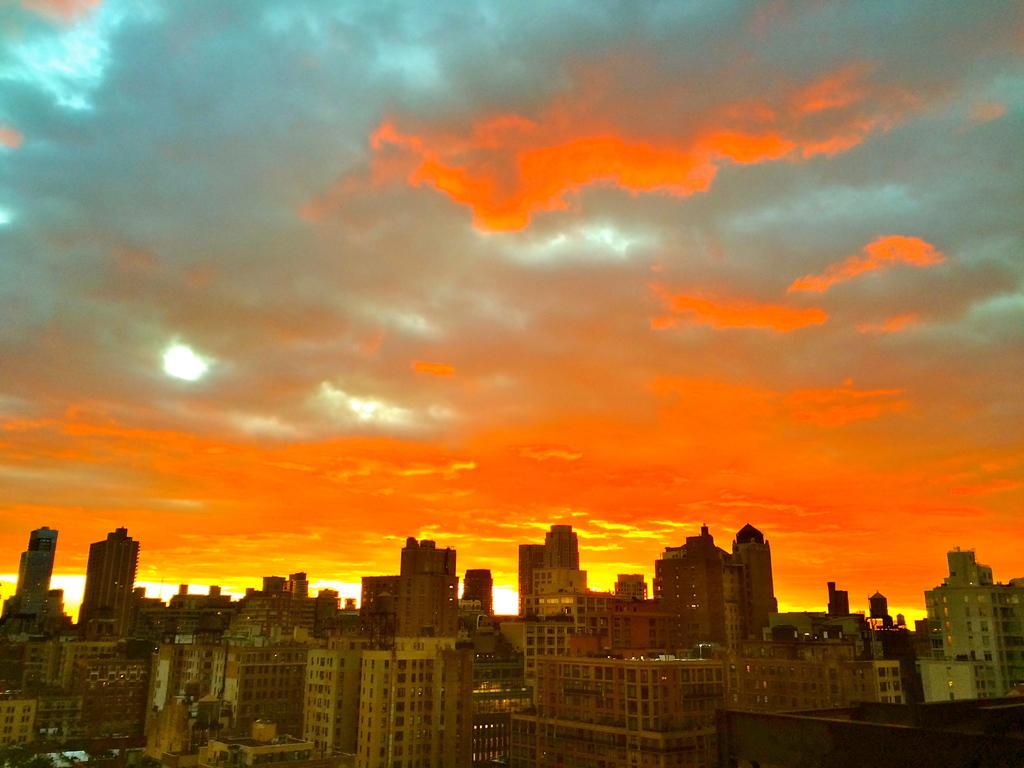Could you give a brief overview of what you see in this image? In this image we can see buildings. In the background there is sky. 